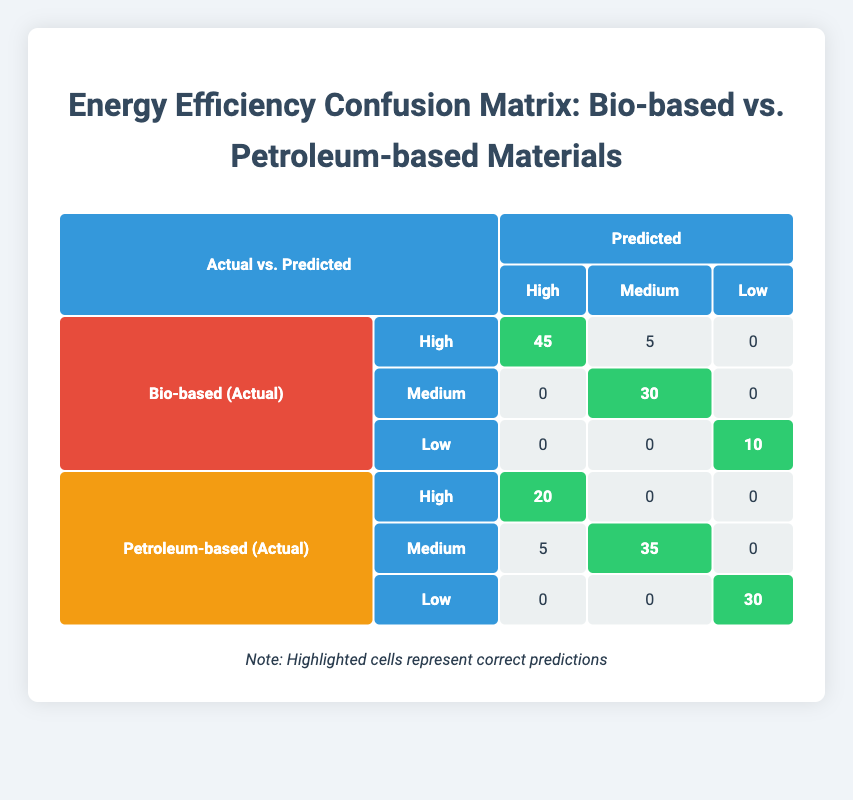What is the total number of actual high-energy efficiency bio-based materials? In the table, under the "Bio-based (Actual)" category, the count for high-energy efficiency materials is 50.
Answer: 50 How many petroleum-based materials were predicted to have medium energy efficiency? In the "Petroleum-based (Actual)" row, the predicted count for medium energy efficiency is 35.
Answer: 35 What is the difference between the actual and predicted counts for low-energy efficiency petroleum-based materials? The actual count for low-energy efficiency petroleum-based materials is 30, while the predicted count is also 30. The difference is 30 - 30 = 0.
Answer: 0 Is it true that all bio-based materials predicted to have low energy efficiency were actually low? Looking at the "Bio-based (Actual)" low row, the predicted count is 10 which matches the actual count. Therefore, it is true.
Answer: Yes What percentage of actual high-energy efficiency petroleum-based materials were correctly predicted? The actual high-energy efficiency count is 20; the predicted correct count for high is also 20. To find the percentage: (20/20) * 100 = 100%.
Answer: 100% How many bio-based materials were incorrectly classified as high energy efficiency? The actual count of bio-based high energy efficiency materials is 50, while the predicted count is 45. The incorrect classifications can be calculated as 50 - 45 = 5.
Answer: 5 What is the combined total of actual high and medium energy efficiency for bio-based materials? The actual high is 50, and the medium is 30. Adding them together gives 50 + 30 = 80.
Answer: 80 What is the total count of bio-based materials compared to petroleum-based materials? The total actual count for bio-based materials is 50 + 30 + 10 = 90. For petroleum-based, it's 20 + 40 + 30 = 90. So both totals are equal.
Answer: Equal 